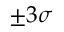Convert formula to latex. <formula><loc_0><loc_0><loc_500><loc_500>\pm 3 \sigma</formula> 